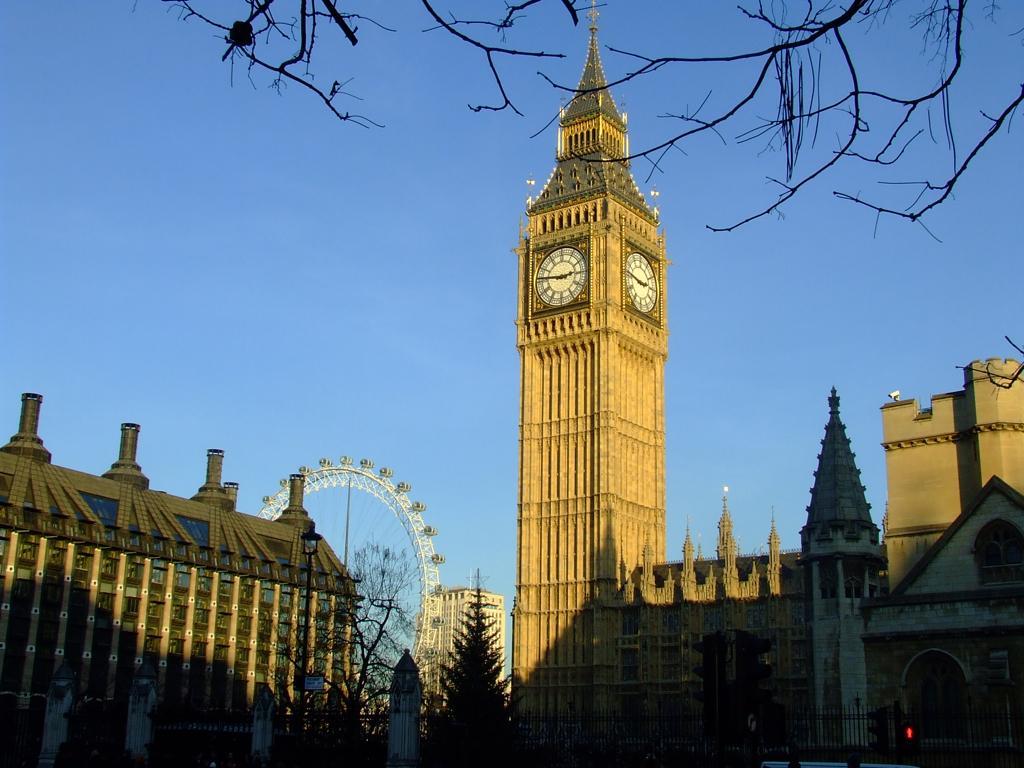How would you summarize this image in a sentence or two? In this picture we can see there is a clock tower and buildings. In front of the buildings, there are trees, a street light and iron grilles. Behind the buildings, there is a "Ferris wheel" and the sky. At the top of the image, there are branches. 